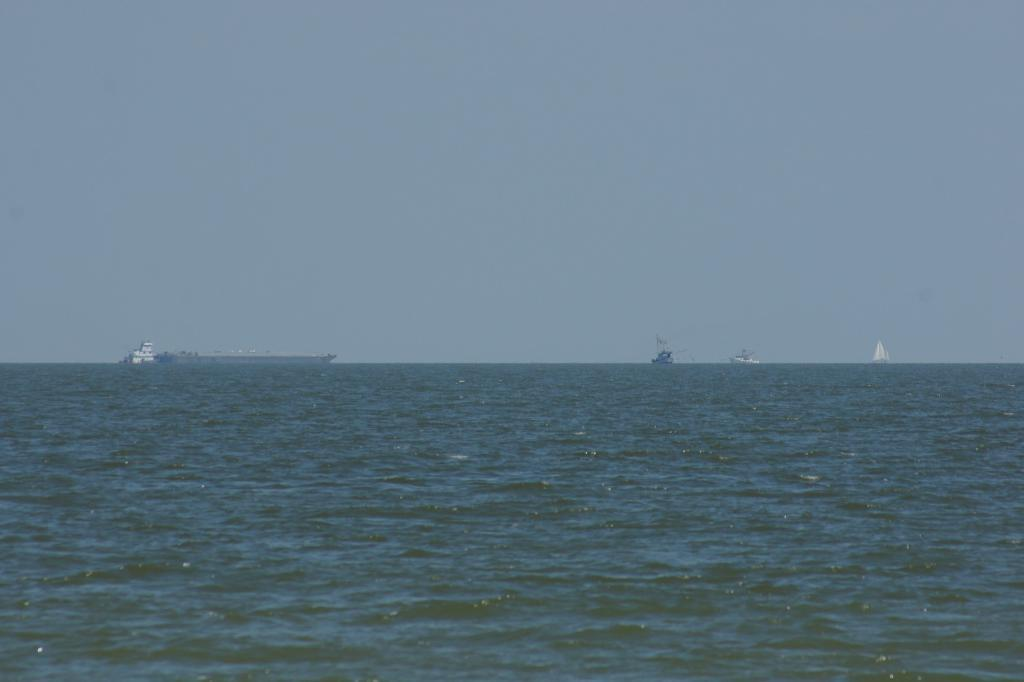What type of body of water is visible in the image? There is an ocean in the image. What is floating on the water in the image? There are ships standing on the water in the image. What is the condition of the sky in the image? The sky is clear and visible in the image. What type of bulb is used to light up the ships in the image? There are no bulbs present in the image, as the ships are standing on the water and not lit up. What form does the ocean take in the image? The ocean is depicted as a large body of water in the image, and its form cannot be described as a specific shape. 